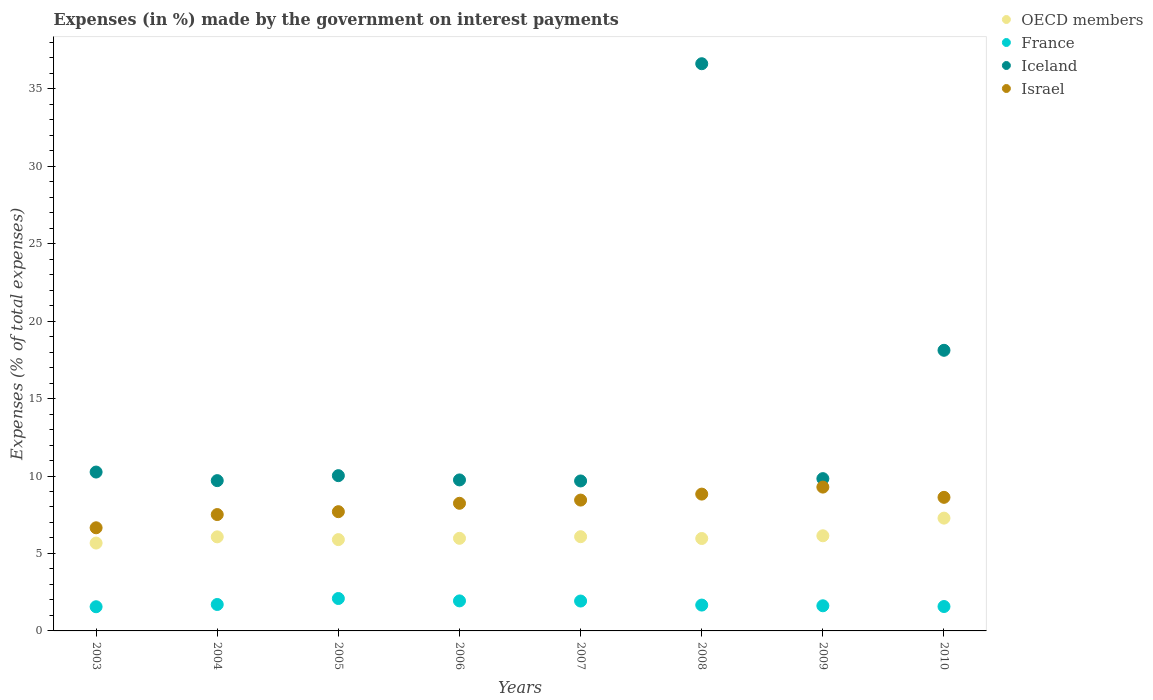How many different coloured dotlines are there?
Offer a very short reply. 4. What is the percentage of expenses made by the government on interest payments in France in 2005?
Make the answer very short. 2.09. Across all years, what is the maximum percentage of expenses made by the government on interest payments in Israel?
Offer a terse response. 9.28. Across all years, what is the minimum percentage of expenses made by the government on interest payments in France?
Offer a terse response. 1.56. In which year was the percentage of expenses made by the government on interest payments in OECD members minimum?
Offer a terse response. 2003. What is the total percentage of expenses made by the government on interest payments in OECD members in the graph?
Provide a short and direct response. 49.08. What is the difference between the percentage of expenses made by the government on interest payments in France in 2007 and that in 2009?
Give a very brief answer. 0.31. What is the difference between the percentage of expenses made by the government on interest payments in OECD members in 2004 and the percentage of expenses made by the government on interest payments in France in 2010?
Provide a short and direct response. 4.5. What is the average percentage of expenses made by the government on interest payments in France per year?
Provide a short and direct response. 1.76. In the year 2009, what is the difference between the percentage of expenses made by the government on interest payments in Iceland and percentage of expenses made by the government on interest payments in France?
Offer a terse response. 8.21. In how many years, is the percentage of expenses made by the government on interest payments in France greater than 9 %?
Make the answer very short. 0. What is the ratio of the percentage of expenses made by the government on interest payments in OECD members in 2006 to that in 2007?
Your answer should be compact. 0.98. Is the percentage of expenses made by the government on interest payments in Israel in 2008 less than that in 2010?
Offer a terse response. No. Is the difference between the percentage of expenses made by the government on interest payments in Iceland in 2006 and 2010 greater than the difference between the percentage of expenses made by the government on interest payments in France in 2006 and 2010?
Your answer should be compact. No. What is the difference between the highest and the second highest percentage of expenses made by the government on interest payments in Iceland?
Provide a succinct answer. 18.5. What is the difference between the highest and the lowest percentage of expenses made by the government on interest payments in Iceland?
Your response must be concise. 26.93. In how many years, is the percentage of expenses made by the government on interest payments in France greater than the average percentage of expenses made by the government on interest payments in France taken over all years?
Offer a terse response. 3. Is it the case that in every year, the sum of the percentage of expenses made by the government on interest payments in OECD members and percentage of expenses made by the government on interest payments in France  is greater than the sum of percentage of expenses made by the government on interest payments in Iceland and percentage of expenses made by the government on interest payments in Israel?
Your answer should be very brief. Yes. Does the percentage of expenses made by the government on interest payments in Iceland monotonically increase over the years?
Give a very brief answer. No. Is the percentage of expenses made by the government on interest payments in Iceland strictly greater than the percentage of expenses made by the government on interest payments in France over the years?
Keep it short and to the point. Yes. Is the percentage of expenses made by the government on interest payments in OECD members strictly less than the percentage of expenses made by the government on interest payments in Israel over the years?
Keep it short and to the point. Yes. How many years are there in the graph?
Make the answer very short. 8. Are the values on the major ticks of Y-axis written in scientific E-notation?
Your answer should be compact. No. Does the graph contain grids?
Your response must be concise. No. Where does the legend appear in the graph?
Give a very brief answer. Top right. How many legend labels are there?
Your answer should be compact. 4. What is the title of the graph?
Your answer should be compact. Expenses (in %) made by the government on interest payments. What is the label or title of the Y-axis?
Provide a succinct answer. Expenses (% of total expenses). What is the Expenses (% of total expenses) of OECD members in 2003?
Your response must be concise. 5.67. What is the Expenses (% of total expenses) of France in 2003?
Your answer should be compact. 1.56. What is the Expenses (% of total expenses) of Iceland in 2003?
Keep it short and to the point. 10.26. What is the Expenses (% of total expenses) of Israel in 2003?
Your response must be concise. 6.66. What is the Expenses (% of total expenses) in OECD members in 2004?
Your answer should be compact. 6.07. What is the Expenses (% of total expenses) in France in 2004?
Make the answer very short. 1.71. What is the Expenses (% of total expenses) in Iceland in 2004?
Provide a succinct answer. 9.7. What is the Expenses (% of total expenses) of Israel in 2004?
Keep it short and to the point. 7.51. What is the Expenses (% of total expenses) of OECD members in 2005?
Give a very brief answer. 5.89. What is the Expenses (% of total expenses) in France in 2005?
Make the answer very short. 2.09. What is the Expenses (% of total expenses) of Iceland in 2005?
Your answer should be compact. 10.02. What is the Expenses (% of total expenses) of Israel in 2005?
Offer a very short reply. 7.7. What is the Expenses (% of total expenses) of OECD members in 2006?
Offer a terse response. 5.98. What is the Expenses (% of total expenses) of France in 2006?
Give a very brief answer. 1.94. What is the Expenses (% of total expenses) in Iceland in 2006?
Offer a very short reply. 9.75. What is the Expenses (% of total expenses) of Israel in 2006?
Keep it short and to the point. 8.24. What is the Expenses (% of total expenses) in OECD members in 2007?
Your answer should be very brief. 6.08. What is the Expenses (% of total expenses) of France in 2007?
Ensure brevity in your answer.  1.93. What is the Expenses (% of total expenses) of Iceland in 2007?
Your response must be concise. 9.68. What is the Expenses (% of total expenses) in Israel in 2007?
Your answer should be very brief. 8.45. What is the Expenses (% of total expenses) of OECD members in 2008?
Offer a terse response. 5.97. What is the Expenses (% of total expenses) in France in 2008?
Offer a terse response. 1.67. What is the Expenses (% of total expenses) in Iceland in 2008?
Provide a succinct answer. 36.61. What is the Expenses (% of total expenses) of Israel in 2008?
Give a very brief answer. 8.83. What is the Expenses (% of total expenses) of OECD members in 2009?
Offer a terse response. 6.14. What is the Expenses (% of total expenses) in France in 2009?
Your answer should be compact. 1.62. What is the Expenses (% of total expenses) of Iceland in 2009?
Keep it short and to the point. 9.83. What is the Expenses (% of total expenses) of Israel in 2009?
Provide a succinct answer. 9.28. What is the Expenses (% of total expenses) in OECD members in 2010?
Provide a succinct answer. 7.28. What is the Expenses (% of total expenses) in France in 2010?
Keep it short and to the point. 1.58. What is the Expenses (% of total expenses) in Iceland in 2010?
Ensure brevity in your answer.  18.11. What is the Expenses (% of total expenses) of Israel in 2010?
Your response must be concise. 8.62. Across all years, what is the maximum Expenses (% of total expenses) of OECD members?
Keep it short and to the point. 7.28. Across all years, what is the maximum Expenses (% of total expenses) in France?
Provide a short and direct response. 2.09. Across all years, what is the maximum Expenses (% of total expenses) of Iceland?
Provide a short and direct response. 36.61. Across all years, what is the maximum Expenses (% of total expenses) of Israel?
Your response must be concise. 9.28. Across all years, what is the minimum Expenses (% of total expenses) of OECD members?
Offer a terse response. 5.67. Across all years, what is the minimum Expenses (% of total expenses) of France?
Your response must be concise. 1.56. Across all years, what is the minimum Expenses (% of total expenses) in Iceland?
Your answer should be very brief. 9.68. Across all years, what is the minimum Expenses (% of total expenses) of Israel?
Keep it short and to the point. 6.66. What is the total Expenses (% of total expenses) of OECD members in the graph?
Your answer should be very brief. 49.08. What is the total Expenses (% of total expenses) in France in the graph?
Keep it short and to the point. 14.09. What is the total Expenses (% of total expenses) in Iceland in the graph?
Provide a succinct answer. 113.96. What is the total Expenses (% of total expenses) in Israel in the graph?
Give a very brief answer. 65.29. What is the difference between the Expenses (% of total expenses) in OECD members in 2003 and that in 2004?
Keep it short and to the point. -0.4. What is the difference between the Expenses (% of total expenses) of France in 2003 and that in 2004?
Make the answer very short. -0.15. What is the difference between the Expenses (% of total expenses) in Iceland in 2003 and that in 2004?
Keep it short and to the point. 0.55. What is the difference between the Expenses (% of total expenses) of Israel in 2003 and that in 2004?
Ensure brevity in your answer.  -0.85. What is the difference between the Expenses (% of total expenses) of OECD members in 2003 and that in 2005?
Provide a short and direct response. -0.22. What is the difference between the Expenses (% of total expenses) of France in 2003 and that in 2005?
Your answer should be very brief. -0.53. What is the difference between the Expenses (% of total expenses) of Iceland in 2003 and that in 2005?
Provide a short and direct response. 0.23. What is the difference between the Expenses (% of total expenses) in Israel in 2003 and that in 2005?
Offer a very short reply. -1.04. What is the difference between the Expenses (% of total expenses) in OECD members in 2003 and that in 2006?
Your response must be concise. -0.31. What is the difference between the Expenses (% of total expenses) in France in 2003 and that in 2006?
Keep it short and to the point. -0.38. What is the difference between the Expenses (% of total expenses) in Iceland in 2003 and that in 2006?
Ensure brevity in your answer.  0.51. What is the difference between the Expenses (% of total expenses) in Israel in 2003 and that in 2006?
Ensure brevity in your answer.  -1.58. What is the difference between the Expenses (% of total expenses) of OECD members in 2003 and that in 2007?
Your answer should be very brief. -0.41. What is the difference between the Expenses (% of total expenses) in France in 2003 and that in 2007?
Your answer should be compact. -0.37. What is the difference between the Expenses (% of total expenses) of Iceland in 2003 and that in 2007?
Keep it short and to the point. 0.57. What is the difference between the Expenses (% of total expenses) of Israel in 2003 and that in 2007?
Your answer should be compact. -1.79. What is the difference between the Expenses (% of total expenses) of OECD members in 2003 and that in 2008?
Keep it short and to the point. -0.29. What is the difference between the Expenses (% of total expenses) in France in 2003 and that in 2008?
Provide a succinct answer. -0.11. What is the difference between the Expenses (% of total expenses) of Iceland in 2003 and that in 2008?
Keep it short and to the point. -26.36. What is the difference between the Expenses (% of total expenses) in Israel in 2003 and that in 2008?
Keep it short and to the point. -2.17. What is the difference between the Expenses (% of total expenses) in OECD members in 2003 and that in 2009?
Offer a terse response. -0.47. What is the difference between the Expenses (% of total expenses) of France in 2003 and that in 2009?
Provide a succinct answer. -0.06. What is the difference between the Expenses (% of total expenses) in Iceland in 2003 and that in 2009?
Your answer should be compact. 0.42. What is the difference between the Expenses (% of total expenses) of Israel in 2003 and that in 2009?
Provide a short and direct response. -2.63. What is the difference between the Expenses (% of total expenses) in OECD members in 2003 and that in 2010?
Provide a short and direct response. -1.61. What is the difference between the Expenses (% of total expenses) in France in 2003 and that in 2010?
Offer a terse response. -0.01. What is the difference between the Expenses (% of total expenses) in Iceland in 2003 and that in 2010?
Ensure brevity in your answer.  -7.86. What is the difference between the Expenses (% of total expenses) in Israel in 2003 and that in 2010?
Ensure brevity in your answer.  -1.96. What is the difference between the Expenses (% of total expenses) of OECD members in 2004 and that in 2005?
Give a very brief answer. 0.18. What is the difference between the Expenses (% of total expenses) of France in 2004 and that in 2005?
Keep it short and to the point. -0.39. What is the difference between the Expenses (% of total expenses) of Iceland in 2004 and that in 2005?
Provide a short and direct response. -0.32. What is the difference between the Expenses (% of total expenses) of Israel in 2004 and that in 2005?
Your response must be concise. -0.19. What is the difference between the Expenses (% of total expenses) in OECD members in 2004 and that in 2006?
Offer a terse response. 0.09. What is the difference between the Expenses (% of total expenses) in France in 2004 and that in 2006?
Your response must be concise. -0.23. What is the difference between the Expenses (% of total expenses) in Iceland in 2004 and that in 2006?
Provide a succinct answer. -0.05. What is the difference between the Expenses (% of total expenses) in Israel in 2004 and that in 2006?
Your answer should be compact. -0.73. What is the difference between the Expenses (% of total expenses) in OECD members in 2004 and that in 2007?
Provide a succinct answer. -0.01. What is the difference between the Expenses (% of total expenses) in France in 2004 and that in 2007?
Your answer should be compact. -0.22. What is the difference between the Expenses (% of total expenses) in Iceland in 2004 and that in 2007?
Your answer should be very brief. 0.02. What is the difference between the Expenses (% of total expenses) in Israel in 2004 and that in 2007?
Your answer should be compact. -0.93. What is the difference between the Expenses (% of total expenses) of OECD members in 2004 and that in 2008?
Your response must be concise. 0.11. What is the difference between the Expenses (% of total expenses) of France in 2004 and that in 2008?
Ensure brevity in your answer.  0.04. What is the difference between the Expenses (% of total expenses) of Iceland in 2004 and that in 2008?
Offer a very short reply. -26.91. What is the difference between the Expenses (% of total expenses) of Israel in 2004 and that in 2008?
Offer a terse response. -1.32. What is the difference between the Expenses (% of total expenses) in OECD members in 2004 and that in 2009?
Your answer should be compact. -0.07. What is the difference between the Expenses (% of total expenses) in France in 2004 and that in 2009?
Make the answer very short. 0.08. What is the difference between the Expenses (% of total expenses) of Iceland in 2004 and that in 2009?
Keep it short and to the point. -0.13. What is the difference between the Expenses (% of total expenses) in Israel in 2004 and that in 2009?
Your response must be concise. -1.77. What is the difference between the Expenses (% of total expenses) in OECD members in 2004 and that in 2010?
Your answer should be very brief. -1.21. What is the difference between the Expenses (% of total expenses) in France in 2004 and that in 2010?
Keep it short and to the point. 0.13. What is the difference between the Expenses (% of total expenses) in Iceland in 2004 and that in 2010?
Your response must be concise. -8.41. What is the difference between the Expenses (% of total expenses) of Israel in 2004 and that in 2010?
Your answer should be very brief. -1.11. What is the difference between the Expenses (% of total expenses) in OECD members in 2005 and that in 2006?
Provide a succinct answer. -0.08. What is the difference between the Expenses (% of total expenses) in France in 2005 and that in 2006?
Your response must be concise. 0.15. What is the difference between the Expenses (% of total expenses) of Iceland in 2005 and that in 2006?
Provide a short and direct response. 0.28. What is the difference between the Expenses (% of total expenses) in Israel in 2005 and that in 2006?
Give a very brief answer. -0.54. What is the difference between the Expenses (% of total expenses) in OECD members in 2005 and that in 2007?
Provide a short and direct response. -0.19. What is the difference between the Expenses (% of total expenses) of France in 2005 and that in 2007?
Make the answer very short. 0.16. What is the difference between the Expenses (% of total expenses) in Iceland in 2005 and that in 2007?
Your answer should be very brief. 0.34. What is the difference between the Expenses (% of total expenses) in Israel in 2005 and that in 2007?
Offer a terse response. -0.75. What is the difference between the Expenses (% of total expenses) in OECD members in 2005 and that in 2008?
Provide a succinct answer. -0.07. What is the difference between the Expenses (% of total expenses) of France in 2005 and that in 2008?
Your response must be concise. 0.42. What is the difference between the Expenses (% of total expenses) of Iceland in 2005 and that in 2008?
Your response must be concise. -26.59. What is the difference between the Expenses (% of total expenses) of Israel in 2005 and that in 2008?
Your answer should be very brief. -1.13. What is the difference between the Expenses (% of total expenses) of OECD members in 2005 and that in 2009?
Keep it short and to the point. -0.25. What is the difference between the Expenses (% of total expenses) in France in 2005 and that in 2009?
Offer a terse response. 0.47. What is the difference between the Expenses (% of total expenses) of Iceland in 2005 and that in 2009?
Keep it short and to the point. 0.19. What is the difference between the Expenses (% of total expenses) in Israel in 2005 and that in 2009?
Give a very brief answer. -1.59. What is the difference between the Expenses (% of total expenses) in OECD members in 2005 and that in 2010?
Offer a terse response. -1.39. What is the difference between the Expenses (% of total expenses) of France in 2005 and that in 2010?
Your answer should be compact. 0.52. What is the difference between the Expenses (% of total expenses) in Iceland in 2005 and that in 2010?
Ensure brevity in your answer.  -8.09. What is the difference between the Expenses (% of total expenses) of Israel in 2005 and that in 2010?
Your answer should be very brief. -0.93. What is the difference between the Expenses (% of total expenses) of OECD members in 2006 and that in 2007?
Ensure brevity in your answer.  -0.1. What is the difference between the Expenses (% of total expenses) in Iceland in 2006 and that in 2007?
Your answer should be compact. 0.07. What is the difference between the Expenses (% of total expenses) of Israel in 2006 and that in 2007?
Your answer should be compact. -0.21. What is the difference between the Expenses (% of total expenses) of OECD members in 2006 and that in 2008?
Make the answer very short. 0.01. What is the difference between the Expenses (% of total expenses) in France in 2006 and that in 2008?
Your response must be concise. 0.27. What is the difference between the Expenses (% of total expenses) in Iceland in 2006 and that in 2008?
Offer a terse response. -26.86. What is the difference between the Expenses (% of total expenses) of Israel in 2006 and that in 2008?
Keep it short and to the point. -0.59. What is the difference between the Expenses (% of total expenses) in OECD members in 2006 and that in 2009?
Make the answer very short. -0.16. What is the difference between the Expenses (% of total expenses) of France in 2006 and that in 2009?
Your answer should be compact. 0.32. What is the difference between the Expenses (% of total expenses) of Iceland in 2006 and that in 2009?
Give a very brief answer. -0.08. What is the difference between the Expenses (% of total expenses) in Israel in 2006 and that in 2009?
Provide a succinct answer. -1.05. What is the difference between the Expenses (% of total expenses) in OECD members in 2006 and that in 2010?
Keep it short and to the point. -1.3. What is the difference between the Expenses (% of total expenses) in France in 2006 and that in 2010?
Give a very brief answer. 0.36. What is the difference between the Expenses (% of total expenses) in Iceland in 2006 and that in 2010?
Give a very brief answer. -8.37. What is the difference between the Expenses (% of total expenses) of Israel in 2006 and that in 2010?
Ensure brevity in your answer.  -0.38. What is the difference between the Expenses (% of total expenses) in OECD members in 2007 and that in 2008?
Provide a succinct answer. 0.12. What is the difference between the Expenses (% of total expenses) in France in 2007 and that in 2008?
Your answer should be very brief. 0.26. What is the difference between the Expenses (% of total expenses) in Iceland in 2007 and that in 2008?
Offer a very short reply. -26.93. What is the difference between the Expenses (% of total expenses) in Israel in 2007 and that in 2008?
Ensure brevity in your answer.  -0.39. What is the difference between the Expenses (% of total expenses) of OECD members in 2007 and that in 2009?
Your response must be concise. -0.06. What is the difference between the Expenses (% of total expenses) in France in 2007 and that in 2009?
Your answer should be very brief. 0.31. What is the difference between the Expenses (% of total expenses) of Iceland in 2007 and that in 2009?
Keep it short and to the point. -0.15. What is the difference between the Expenses (% of total expenses) of Israel in 2007 and that in 2009?
Your answer should be very brief. -0.84. What is the difference between the Expenses (% of total expenses) in OECD members in 2007 and that in 2010?
Make the answer very short. -1.2. What is the difference between the Expenses (% of total expenses) in France in 2007 and that in 2010?
Ensure brevity in your answer.  0.35. What is the difference between the Expenses (% of total expenses) of Iceland in 2007 and that in 2010?
Give a very brief answer. -8.43. What is the difference between the Expenses (% of total expenses) in Israel in 2007 and that in 2010?
Make the answer very short. -0.18. What is the difference between the Expenses (% of total expenses) of OECD members in 2008 and that in 2009?
Your response must be concise. -0.18. What is the difference between the Expenses (% of total expenses) in France in 2008 and that in 2009?
Your answer should be compact. 0.05. What is the difference between the Expenses (% of total expenses) in Iceland in 2008 and that in 2009?
Provide a short and direct response. 26.78. What is the difference between the Expenses (% of total expenses) of Israel in 2008 and that in 2009?
Your answer should be compact. -0.45. What is the difference between the Expenses (% of total expenses) in OECD members in 2008 and that in 2010?
Provide a short and direct response. -1.32. What is the difference between the Expenses (% of total expenses) in France in 2008 and that in 2010?
Ensure brevity in your answer.  0.09. What is the difference between the Expenses (% of total expenses) in Iceland in 2008 and that in 2010?
Offer a very short reply. 18.5. What is the difference between the Expenses (% of total expenses) of Israel in 2008 and that in 2010?
Make the answer very short. 0.21. What is the difference between the Expenses (% of total expenses) in OECD members in 2009 and that in 2010?
Your response must be concise. -1.14. What is the difference between the Expenses (% of total expenses) in France in 2009 and that in 2010?
Provide a short and direct response. 0.05. What is the difference between the Expenses (% of total expenses) in Iceland in 2009 and that in 2010?
Make the answer very short. -8.28. What is the difference between the Expenses (% of total expenses) in Israel in 2009 and that in 2010?
Provide a succinct answer. 0.66. What is the difference between the Expenses (% of total expenses) in OECD members in 2003 and the Expenses (% of total expenses) in France in 2004?
Make the answer very short. 3.96. What is the difference between the Expenses (% of total expenses) in OECD members in 2003 and the Expenses (% of total expenses) in Iceland in 2004?
Offer a terse response. -4.03. What is the difference between the Expenses (% of total expenses) in OECD members in 2003 and the Expenses (% of total expenses) in Israel in 2004?
Give a very brief answer. -1.84. What is the difference between the Expenses (% of total expenses) of France in 2003 and the Expenses (% of total expenses) of Iceland in 2004?
Make the answer very short. -8.14. What is the difference between the Expenses (% of total expenses) of France in 2003 and the Expenses (% of total expenses) of Israel in 2004?
Make the answer very short. -5.95. What is the difference between the Expenses (% of total expenses) of Iceland in 2003 and the Expenses (% of total expenses) of Israel in 2004?
Your answer should be compact. 2.74. What is the difference between the Expenses (% of total expenses) in OECD members in 2003 and the Expenses (% of total expenses) in France in 2005?
Your response must be concise. 3.58. What is the difference between the Expenses (% of total expenses) of OECD members in 2003 and the Expenses (% of total expenses) of Iceland in 2005?
Offer a very short reply. -4.35. What is the difference between the Expenses (% of total expenses) in OECD members in 2003 and the Expenses (% of total expenses) in Israel in 2005?
Offer a very short reply. -2.03. What is the difference between the Expenses (% of total expenses) of France in 2003 and the Expenses (% of total expenses) of Iceland in 2005?
Provide a short and direct response. -8.46. What is the difference between the Expenses (% of total expenses) of France in 2003 and the Expenses (% of total expenses) of Israel in 2005?
Give a very brief answer. -6.14. What is the difference between the Expenses (% of total expenses) in Iceland in 2003 and the Expenses (% of total expenses) in Israel in 2005?
Give a very brief answer. 2.56. What is the difference between the Expenses (% of total expenses) in OECD members in 2003 and the Expenses (% of total expenses) in France in 2006?
Make the answer very short. 3.73. What is the difference between the Expenses (% of total expenses) in OECD members in 2003 and the Expenses (% of total expenses) in Iceland in 2006?
Offer a very short reply. -4.08. What is the difference between the Expenses (% of total expenses) in OECD members in 2003 and the Expenses (% of total expenses) in Israel in 2006?
Ensure brevity in your answer.  -2.57. What is the difference between the Expenses (% of total expenses) in France in 2003 and the Expenses (% of total expenses) in Iceland in 2006?
Your answer should be very brief. -8.19. What is the difference between the Expenses (% of total expenses) in France in 2003 and the Expenses (% of total expenses) in Israel in 2006?
Offer a terse response. -6.68. What is the difference between the Expenses (% of total expenses) in Iceland in 2003 and the Expenses (% of total expenses) in Israel in 2006?
Give a very brief answer. 2.02. What is the difference between the Expenses (% of total expenses) in OECD members in 2003 and the Expenses (% of total expenses) in France in 2007?
Keep it short and to the point. 3.74. What is the difference between the Expenses (% of total expenses) in OECD members in 2003 and the Expenses (% of total expenses) in Iceland in 2007?
Offer a terse response. -4.01. What is the difference between the Expenses (% of total expenses) of OECD members in 2003 and the Expenses (% of total expenses) of Israel in 2007?
Ensure brevity in your answer.  -2.77. What is the difference between the Expenses (% of total expenses) of France in 2003 and the Expenses (% of total expenses) of Iceland in 2007?
Give a very brief answer. -8.12. What is the difference between the Expenses (% of total expenses) in France in 2003 and the Expenses (% of total expenses) in Israel in 2007?
Provide a short and direct response. -6.88. What is the difference between the Expenses (% of total expenses) in Iceland in 2003 and the Expenses (% of total expenses) in Israel in 2007?
Give a very brief answer. 1.81. What is the difference between the Expenses (% of total expenses) in OECD members in 2003 and the Expenses (% of total expenses) in France in 2008?
Keep it short and to the point. 4. What is the difference between the Expenses (% of total expenses) in OECD members in 2003 and the Expenses (% of total expenses) in Iceland in 2008?
Your answer should be compact. -30.94. What is the difference between the Expenses (% of total expenses) of OECD members in 2003 and the Expenses (% of total expenses) of Israel in 2008?
Provide a succinct answer. -3.16. What is the difference between the Expenses (% of total expenses) of France in 2003 and the Expenses (% of total expenses) of Iceland in 2008?
Keep it short and to the point. -35.05. What is the difference between the Expenses (% of total expenses) in France in 2003 and the Expenses (% of total expenses) in Israel in 2008?
Your response must be concise. -7.27. What is the difference between the Expenses (% of total expenses) in Iceland in 2003 and the Expenses (% of total expenses) in Israel in 2008?
Keep it short and to the point. 1.42. What is the difference between the Expenses (% of total expenses) in OECD members in 2003 and the Expenses (% of total expenses) in France in 2009?
Make the answer very short. 4.05. What is the difference between the Expenses (% of total expenses) in OECD members in 2003 and the Expenses (% of total expenses) in Iceland in 2009?
Make the answer very short. -4.16. What is the difference between the Expenses (% of total expenses) in OECD members in 2003 and the Expenses (% of total expenses) in Israel in 2009?
Provide a short and direct response. -3.61. What is the difference between the Expenses (% of total expenses) of France in 2003 and the Expenses (% of total expenses) of Iceland in 2009?
Provide a succinct answer. -8.27. What is the difference between the Expenses (% of total expenses) in France in 2003 and the Expenses (% of total expenses) in Israel in 2009?
Provide a short and direct response. -7.72. What is the difference between the Expenses (% of total expenses) of Iceland in 2003 and the Expenses (% of total expenses) of Israel in 2009?
Your answer should be compact. 0.97. What is the difference between the Expenses (% of total expenses) in OECD members in 2003 and the Expenses (% of total expenses) in France in 2010?
Your answer should be very brief. 4.1. What is the difference between the Expenses (% of total expenses) in OECD members in 2003 and the Expenses (% of total expenses) in Iceland in 2010?
Your response must be concise. -12.44. What is the difference between the Expenses (% of total expenses) in OECD members in 2003 and the Expenses (% of total expenses) in Israel in 2010?
Ensure brevity in your answer.  -2.95. What is the difference between the Expenses (% of total expenses) of France in 2003 and the Expenses (% of total expenses) of Iceland in 2010?
Offer a very short reply. -16.55. What is the difference between the Expenses (% of total expenses) of France in 2003 and the Expenses (% of total expenses) of Israel in 2010?
Give a very brief answer. -7.06. What is the difference between the Expenses (% of total expenses) in Iceland in 2003 and the Expenses (% of total expenses) in Israel in 2010?
Your answer should be compact. 1.63. What is the difference between the Expenses (% of total expenses) in OECD members in 2004 and the Expenses (% of total expenses) in France in 2005?
Offer a terse response. 3.98. What is the difference between the Expenses (% of total expenses) of OECD members in 2004 and the Expenses (% of total expenses) of Iceland in 2005?
Provide a succinct answer. -3.95. What is the difference between the Expenses (% of total expenses) of OECD members in 2004 and the Expenses (% of total expenses) of Israel in 2005?
Provide a succinct answer. -1.62. What is the difference between the Expenses (% of total expenses) of France in 2004 and the Expenses (% of total expenses) of Iceland in 2005?
Provide a succinct answer. -8.32. What is the difference between the Expenses (% of total expenses) of France in 2004 and the Expenses (% of total expenses) of Israel in 2005?
Provide a short and direct response. -5.99. What is the difference between the Expenses (% of total expenses) in Iceland in 2004 and the Expenses (% of total expenses) in Israel in 2005?
Provide a succinct answer. 2. What is the difference between the Expenses (% of total expenses) of OECD members in 2004 and the Expenses (% of total expenses) of France in 2006?
Your response must be concise. 4.13. What is the difference between the Expenses (% of total expenses) of OECD members in 2004 and the Expenses (% of total expenses) of Iceland in 2006?
Give a very brief answer. -3.68. What is the difference between the Expenses (% of total expenses) of OECD members in 2004 and the Expenses (% of total expenses) of Israel in 2006?
Provide a succinct answer. -2.17. What is the difference between the Expenses (% of total expenses) in France in 2004 and the Expenses (% of total expenses) in Iceland in 2006?
Give a very brief answer. -8.04. What is the difference between the Expenses (% of total expenses) of France in 2004 and the Expenses (% of total expenses) of Israel in 2006?
Offer a very short reply. -6.53. What is the difference between the Expenses (% of total expenses) of Iceland in 2004 and the Expenses (% of total expenses) of Israel in 2006?
Keep it short and to the point. 1.46. What is the difference between the Expenses (% of total expenses) of OECD members in 2004 and the Expenses (% of total expenses) of France in 2007?
Ensure brevity in your answer.  4.14. What is the difference between the Expenses (% of total expenses) in OECD members in 2004 and the Expenses (% of total expenses) in Iceland in 2007?
Your answer should be compact. -3.61. What is the difference between the Expenses (% of total expenses) in OECD members in 2004 and the Expenses (% of total expenses) in Israel in 2007?
Provide a short and direct response. -2.37. What is the difference between the Expenses (% of total expenses) in France in 2004 and the Expenses (% of total expenses) in Iceland in 2007?
Your response must be concise. -7.97. What is the difference between the Expenses (% of total expenses) of France in 2004 and the Expenses (% of total expenses) of Israel in 2007?
Your answer should be compact. -6.74. What is the difference between the Expenses (% of total expenses) in Iceland in 2004 and the Expenses (% of total expenses) in Israel in 2007?
Your answer should be compact. 1.26. What is the difference between the Expenses (% of total expenses) in OECD members in 2004 and the Expenses (% of total expenses) in France in 2008?
Provide a succinct answer. 4.4. What is the difference between the Expenses (% of total expenses) in OECD members in 2004 and the Expenses (% of total expenses) in Iceland in 2008?
Make the answer very short. -30.54. What is the difference between the Expenses (% of total expenses) of OECD members in 2004 and the Expenses (% of total expenses) of Israel in 2008?
Your response must be concise. -2.76. What is the difference between the Expenses (% of total expenses) of France in 2004 and the Expenses (% of total expenses) of Iceland in 2008?
Offer a terse response. -34.91. What is the difference between the Expenses (% of total expenses) in France in 2004 and the Expenses (% of total expenses) in Israel in 2008?
Ensure brevity in your answer.  -7.12. What is the difference between the Expenses (% of total expenses) in Iceland in 2004 and the Expenses (% of total expenses) in Israel in 2008?
Provide a short and direct response. 0.87. What is the difference between the Expenses (% of total expenses) of OECD members in 2004 and the Expenses (% of total expenses) of France in 2009?
Give a very brief answer. 4.45. What is the difference between the Expenses (% of total expenses) of OECD members in 2004 and the Expenses (% of total expenses) of Iceland in 2009?
Keep it short and to the point. -3.76. What is the difference between the Expenses (% of total expenses) of OECD members in 2004 and the Expenses (% of total expenses) of Israel in 2009?
Make the answer very short. -3.21. What is the difference between the Expenses (% of total expenses) in France in 2004 and the Expenses (% of total expenses) in Iceland in 2009?
Your answer should be compact. -8.12. What is the difference between the Expenses (% of total expenses) in France in 2004 and the Expenses (% of total expenses) in Israel in 2009?
Provide a succinct answer. -7.58. What is the difference between the Expenses (% of total expenses) of Iceland in 2004 and the Expenses (% of total expenses) of Israel in 2009?
Provide a succinct answer. 0.42. What is the difference between the Expenses (% of total expenses) in OECD members in 2004 and the Expenses (% of total expenses) in France in 2010?
Offer a very short reply. 4.5. What is the difference between the Expenses (% of total expenses) of OECD members in 2004 and the Expenses (% of total expenses) of Iceland in 2010?
Your response must be concise. -12.04. What is the difference between the Expenses (% of total expenses) in OECD members in 2004 and the Expenses (% of total expenses) in Israel in 2010?
Offer a terse response. -2.55. What is the difference between the Expenses (% of total expenses) in France in 2004 and the Expenses (% of total expenses) in Iceland in 2010?
Ensure brevity in your answer.  -16.41. What is the difference between the Expenses (% of total expenses) in France in 2004 and the Expenses (% of total expenses) in Israel in 2010?
Keep it short and to the point. -6.92. What is the difference between the Expenses (% of total expenses) in Iceland in 2004 and the Expenses (% of total expenses) in Israel in 2010?
Offer a very short reply. 1.08. What is the difference between the Expenses (% of total expenses) of OECD members in 2005 and the Expenses (% of total expenses) of France in 2006?
Keep it short and to the point. 3.96. What is the difference between the Expenses (% of total expenses) of OECD members in 2005 and the Expenses (% of total expenses) of Iceland in 2006?
Your answer should be very brief. -3.85. What is the difference between the Expenses (% of total expenses) of OECD members in 2005 and the Expenses (% of total expenses) of Israel in 2006?
Ensure brevity in your answer.  -2.34. What is the difference between the Expenses (% of total expenses) of France in 2005 and the Expenses (% of total expenses) of Iceland in 2006?
Offer a terse response. -7.65. What is the difference between the Expenses (% of total expenses) of France in 2005 and the Expenses (% of total expenses) of Israel in 2006?
Your answer should be compact. -6.15. What is the difference between the Expenses (% of total expenses) in Iceland in 2005 and the Expenses (% of total expenses) in Israel in 2006?
Your response must be concise. 1.78. What is the difference between the Expenses (% of total expenses) of OECD members in 2005 and the Expenses (% of total expenses) of France in 2007?
Give a very brief answer. 3.97. What is the difference between the Expenses (% of total expenses) of OECD members in 2005 and the Expenses (% of total expenses) of Iceland in 2007?
Keep it short and to the point. -3.79. What is the difference between the Expenses (% of total expenses) of OECD members in 2005 and the Expenses (% of total expenses) of Israel in 2007?
Give a very brief answer. -2.55. What is the difference between the Expenses (% of total expenses) in France in 2005 and the Expenses (% of total expenses) in Iceland in 2007?
Ensure brevity in your answer.  -7.59. What is the difference between the Expenses (% of total expenses) in France in 2005 and the Expenses (% of total expenses) in Israel in 2007?
Provide a short and direct response. -6.35. What is the difference between the Expenses (% of total expenses) in Iceland in 2005 and the Expenses (% of total expenses) in Israel in 2007?
Give a very brief answer. 1.58. What is the difference between the Expenses (% of total expenses) in OECD members in 2005 and the Expenses (% of total expenses) in France in 2008?
Your answer should be very brief. 4.23. What is the difference between the Expenses (% of total expenses) in OECD members in 2005 and the Expenses (% of total expenses) in Iceland in 2008?
Offer a terse response. -30.72. What is the difference between the Expenses (% of total expenses) of OECD members in 2005 and the Expenses (% of total expenses) of Israel in 2008?
Your answer should be compact. -2.94. What is the difference between the Expenses (% of total expenses) in France in 2005 and the Expenses (% of total expenses) in Iceland in 2008?
Ensure brevity in your answer.  -34.52. What is the difference between the Expenses (% of total expenses) of France in 2005 and the Expenses (% of total expenses) of Israel in 2008?
Give a very brief answer. -6.74. What is the difference between the Expenses (% of total expenses) in Iceland in 2005 and the Expenses (% of total expenses) in Israel in 2008?
Keep it short and to the point. 1.19. What is the difference between the Expenses (% of total expenses) in OECD members in 2005 and the Expenses (% of total expenses) in France in 2009?
Ensure brevity in your answer.  4.27. What is the difference between the Expenses (% of total expenses) of OECD members in 2005 and the Expenses (% of total expenses) of Iceland in 2009?
Give a very brief answer. -3.94. What is the difference between the Expenses (% of total expenses) of OECD members in 2005 and the Expenses (% of total expenses) of Israel in 2009?
Keep it short and to the point. -3.39. What is the difference between the Expenses (% of total expenses) of France in 2005 and the Expenses (% of total expenses) of Iceland in 2009?
Your answer should be compact. -7.74. What is the difference between the Expenses (% of total expenses) of France in 2005 and the Expenses (% of total expenses) of Israel in 2009?
Your response must be concise. -7.19. What is the difference between the Expenses (% of total expenses) in Iceland in 2005 and the Expenses (% of total expenses) in Israel in 2009?
Ensure brevity in your answer.  0.74. What is the difference between the Expenses (% of total expenses) of OECD members in 2005 and the Expenses (% of total expenses) of France in 2010?
Your answer should be very brief. 4.32. What is the difference between the Expenses (% of total expenses) in OECD members in 2005 and the Expenses (% of total expenses) in Iceland in 2010?
Your answer should be very brief. -12.22. What is the difference between the Expenses (% of total expenses) of OECD members in 2005 and the Expenses (% of total expenses) of Israel in 2010?
Your response must be concise. -2.73. What is the difference between the Expenses (% of total expenses) of France in 2005 and the Expenses (% of total expenses) of Iceland in 2010?
Ensure brevity in your answer.  -16.02. What is the difference between the Expenses (% of total expenses) in France in 2005 and the Expenses (% of total expenses) in Israel in 2010?
Provide a succinct answer. -6.53. What is the difference between the Expenses (% of total expenses) in Iceland in 2005 and the Expenses (% of total expenses) in Israel in 2010?
Offer a terse response. 1.4. What is the difference between the Expenses (% of total expenses) of OECD members in 2006 and the Expenses (% of total expenses) of France in 2007?
Ensure brevity in your answer.  4.05. What is the difference between the Expenses (% of total expenses) in OECD members in 2006 and the Expenses (% of total expenses) in Iceland in 2007?
Your answer should be very brief. -3.7. What is the difference between the Expenses (% of total expenses) in OECD members in 2006 and the Expenses (% of total expenses) in Israel in 2007?
Ensure brevity in your answer.  -2.47. What is the difference between the Expenses (% of total expenses) of France in 2006 and the Expenses (% of total expenses) of Iceland in 2007?
Offer a very short reply. -7.74. What is the difference between the Expenses (% of total expenses) of France in 2006 and the Expenses (% of total expenses) of Israel in 2007?
Offer a terse response. -6.51. What is the difference between the Expenses (% of total expenses) of Iceland in 2006 and the Expenses (% of total expenses) of Israel in 2007?
Your answer should be very brief. 1.3. What is the difference between the Expenses (% of total expenses) of OECD members in 2006 and the Expenses (% of total expenses) of France in 2008?
Your response must be concise. 4.31. What is the difference between the Expenses (% of total expenses) of OECD members in 2006 and the Expenses (% of total expenses) of Iceland in 2008?
Make the answer very short. -30.63. What is the difference between the Expenses (% of total expenses) in OECD members in 2006 and the Expenses (% of total expenses) in Israel in 2008?
Keep it short and to the point. -2.85. What is the difference between the Expenses (% of total expenses) in France in 2006 and the Expenses (% of total expenses) in Iceland in 2008?
Offer a very short reply. -34.67. What is the difference between the Expenses (% of total expenses) in France in 2006 and the Expenses (% of total expenses) in Israel in 2008?
Make the answer very short. -6.89. What is the difference between the Expenses (% of total expenses) in Iceland in 2006 and the Expenses (% of total expenses) in Israel in 2008?
Provide a succinct answer. 0.92. What is the difference between the Expenses (% of total expenses) of OECD members in 2006 and the Expenses (% of total expenses) of France in 2009?
Your response must be concise. 4.35. What is the difference between the Expenses (% of total expenses) in OECD members in 2006 and the Expenses (% of total expenses) in Iceland in 2009?
Make the answer very short. -3.85. What is the difference between the Expenses (% of total expenses) of OECD members in 2006 and the Expenses (% of total expenses) of Israel in 2009?
Make the answer very short. -3.31. What is the difference between the Expenses (% of total expenses) in France in 2006 and the Expenses (% of total expenses) in Iceland in 2009?
Ensure brevity in your answer.  -7.89. What is the difference between the Expenses (% of total expenses) in France in 2006 and the Expenses (% of total expenses) in Israel in 2009?
Provide a short and direct response. -7.35. What is the difference between the Expenses (% of total expenses) in Iceland in 2006 and the Expenses (% of total expenses) in Israel in 2009?
Offer a very short reply. 0.46. What is the difference between the Expenses (% of total expenses) of OECD members in 2006 and the Expenses (% of total expenses) of France in 2010?
Your answer should be compact. 4.4. What is the difference between the Expenses (% of total expenses) in OECD members in 2006 and the Expenses (% of total expenses) in Iceland in 2010?
Offer a terse response. -12.14. What is the difference between the Expenses (% of total expenses) in OECD members in 2006 and the Expenses (% of total expenses) in Israel in 2010?
Keep it short and to the point. -2.64. What is the difference between the Expenses (% of total expenses) in France in 2006 and the Expenses (% of total expenses) in Iceland in 2010?
Your response must be concise. -16.18. What is the difference between the Expenses (% of total expenses) of France in 2006 and the Expenses (% of total expenses) of Israel in 2010?
Offer a very short reply. -6.68. What is the difference between the Expenses (% of total expenses) of Iceland in 2006 and the Expenses (% of total expenses) of Israel in 2010?
Provide a succinct answer. 1.12. What is the difference between the Expenses (% of total expenses) in OECD members in 2007 and the Expenses (% of total expenses) in France in 2008?
Your answer should be very brief. 4.41. What is the difference between the Expenses (% of total expenses) in OECD members in 2007 and the Expenses (% of total expenses) in Iceland in 2008?
Make the answer very short. -30.53. What is the difference between the Expenses (% of total expenses) in OECD members in 2007 and the Expenses (% of total expenses) in Israel in 2008?
Provide a succinct answer. -2.75. What is the difference between the Expenses (% of total expenses) of France in 2007 and the Expenses (% of total expenses) of Iceland in 2008?
Keep it short and to the point. -34.68. What is the difference between the Expenses (% of total expenses) in France in 2007 and the Expenses (% of total expenses) in Israel in 2008?
Your response must be concise. -6.9. What is the difference between the Expenses (% of total expenses) in Iceland in 2007 and the Expenses (% of total expenses) in Israel in 2008?
Make the answer very short. 0.85. What is the difference between the Expenses (% of total expenses) in OECD members in 2007 and the Expenses (% of total expenses) in France in 2009?
Your answer should be compact. 4.46. What is the difference between the Expenses (% of total expenses) of OECD members in 2007 and the Expenses (% of total expenses) of Iceland in 2009?
Ensure brevity in your answer.  -3.75. What is the difference between the Expenses (% of total expenses) in OECD members in 2007 and the Expenses (% of total expenses) in Israel in 2009?
Provide a succinct answer. -3.2. What is the difference between the Expenses (% of total expenses) in France in 2007 and the Expenses (% of total expenses) in Iceland in 2009?
Ensure brevity in your answer.  -7.9. What is the difference between the Expenses (% of total expenses) of France in 2007 and the Expenses (% of total expenses) of Israel in 2009?
Your answer should be compact. -7.36. What is the difference between the Expenses (% of total expenses) in Iceland in 2007 and the Expenses (% of total expenses) in Israel in 2009?
Keep it short and to the point. 0.4. What is the difference between the Expenses (% of total expenses) of OECD members in 2007 and the Expenses (% of total expenses) of France in 2010?
Give a very brief answer. 4.51. What is the difference between the Expenses (% of total expenses) of OECD members in 2007 and the Expenses (% of total expenses) of Iceland in 2010?
Provide a succinct answer. -12.03. What is the difference between the Expenses (% of total expenses) in OECD members in 2007 and the Expenses (% of total expenses) in Israel in 2010?
Provide a succinct answer. -2.54. What is the difference between the Expenses (% of total expenses) of France in 2007 and the Expenses (% of total expenses) of Iceland in 2010?
Give a very brief answer. -16.19. What is the difference between the Expenses (% of total expenses) in France in 2007 and the Expenses (% of total expenses) in Israel in 2010?
Offer a terse response. -6.69. What is the difference between the Expenses (% of total expenses) in Iceland in 2007 and the Expenses (% of total expenses) in Israel in 2010?
Offer a very short reply. 1.06. What is the difference between the Expenses (% of total expenses) of OECD members in 2008 and the Expenses (% of total expenses) of France in 2009?
Offer a terse response. 4.34. What is the difference between the Expenses (% of total expenses) of OECD members in 2008 and the Expenses (% of total expenses) of Iceland in 2009?
Keep it short and to the point. -3.86. What is the difference between the Expenses (% of total expenses) in OECD members in 2008 and the Expenses (% of total expenses) in Israel in 2009?
Provide a succinct answer. -3.32. What is the difference between the Expenses (% of total expenses) in France in 2008 and the Expenses (% of total expenses) in Iceland in 2009?
Provide a short and direct response. -8.16. What is the difference between the Expenses (% of total expenses) of France in 2008 and the Expenses (% of total expenses) of Israel in 2009?
Ensure brevity in your answer.  -7.62. What is the difference between the Expenses (% of total expenses) of Iceland in 2008 and the Expenses (% of total expenses) of Israel in 2009?
Give a very brief answer. 27.33. What is the difference between the Expenses (% of total expenses) of OECD members in 2008 and the Expenses (% of total expenses) of France in 2010?
Provide a succinct answer. 4.39. What is the difference between the Expenses (% of total expenses) in OECD members in 2008 and the Expenses (% of total expenses) in Iceland in 2010?
Offer a very short reply. -12.15. What is the difference between the Expenses (% of total expenses) in OECD members in 2008 and the Expenses (% of total expenses) in Israel in 2010?
Your response must be concise. -2.66. What is the difference between the Expenses (% of total expenses) of France in 2008 and the Expenses (% of total expenses) of Iceland in 2010?
Offer a terse response. -16.45. What is the difference between the Expenses (% of total expenses) in France in 2008 and the Expenses (% of total expenses) in Israel in 2010?
Provide a short and direct response. -6.95. What is the difference between the Expenses (% of total expenses) of Iceland in 2008 and the Expenses (% of total expenses) of Israel in 2010?
Make the answer very short. 27.99. What is the difference between the Expenses (% of total expenses) in OECD members in 2009 and the Expenses (% of total expenses) in France in 2010?
Your answer should be compact. 4.57. What is the difference between the Expenses (% of total expenses) in OECD members in 2009 and the Expenses (% of total expenses) in Iceland in 2010?
Keep it short and to the point. -11.97. What is the difference between the Expenses (% of total expenses) in OECD members in 2009 and the Expenses (% of total expenses) in Israel in 2010?
Offer a very short reply. -2.48. What is the difference between the Expenses (% of total expenses) of France in 2009 and the Expenses (% of total expenses) of Iceland in 2010?
Your response must be concise. -16.49. What is the difference between the Expenses (% of total expenses) of France in 2009 and the Expenses (% of total expenses) of Israel in 2010?
Ensure brevity in your answer.  -7. What is the difference between the Expenses (% of total expenses) in Iceland in 2009 and the Expenses (% of total expenses) in Israel in 2010?
Provide a succinct answer. 1.21. What is the average Expenses (% of total expenses) of OECD members per year?
Provide a short and direct response. 6.14. What is the average Expenses (% of total expenses) of France per year?
Ensure brevity in your answer.  1.76. What is the average Expenses (% of total expenses) of Iceland per year?
Provide a succinct answer. 14.25. What is the average Expenses (% of total expenses) of Israel per year?
Ensure brevity in your answer.  8.16. In the year 2003, what is the difference between the Expenses (% of total expenses) of OECD members and Expenses (% of total expenses) of France?
Offer a terse response. 4.11. In the year 2003, what is the difference between the Expenses (% of total expenses) in OECD members and Expenses (% of total expenses) in Iceland?
Provide a short and direct response. -4.58. In the year 2003, what is the difference between the Expenses (% of total expenses) of OECD members and Expenses (% of total expenses) of Israel?
Ensure brevity in your answer.  -0.99. In the year 2003, what is the difference between the Expenses (% of total expenses) in France and Expenses (% of total expenses) in Iceland?
Provide a succinct answer. -8.69. In the year 2003, what is the difference between the Expenses (% of total expenses) of France and Expenses (% of total expenses) of Israel?
Your response must be concise. -5.1. In the year 2003, what is the difference between the Expenses (% of total expenses) of Iceland and Expenses (% of total expenses) of Israel?
Your answer should be compact. 3.6. In the year 2004, what is the difference between the Expenses (% of total expenses) in OECD members and Expenses (% of total expenses) in France?
Provide a succinct answer. 4.37. In the year 2004, what is the difference between the Expenses (% of total expenses) of OECD members and Expenses (% of total expenses) of Iceland?
Your answer should be very brief. -3.63. In the year 2004, what is the difference between the Expenses (% of total expenses) in OECD members and Expenses (% of total expenses) in Israel?
Provide a short and direct response. -1.44. In the year 2004, what is the difference between the Expenses (% of total expenses) in France and Expenses (% of total expenses) in Iceland?
Provide a short and direct response. -7.99. In the year 2004, what is the difference between the Expenses (% of total expenses) of France and Expenses (% of total expenses) of Israel?
Your response must be concise. -5.8. In the year 2004, what is the difference between the Expenses (% of total expenses) in Iceland and Expenses (% of total expenses) in Israel?
Your answer should be compact. 2.19. In the year 2005, what is the difference between the Expenses (% of total expenses) in OECD members and Expenses (% of total expenses) in France?
Give a very brief answer. 3.8. In the year 2005, what is the difference between the Expenses (% of total expenses) of OECD members and Expenses (% of total expenses) of Iceland?
Offer a very short reply. -4.13. In the year 2005, what is the difference between the Expenses (% of total expenses) in OECD members and Expenses (% of total expenses) in Israel?
Make the answer very short. -1.8. In the year 2005, what is the difference between the Expenses (% of total expenses) in France and Expenses (% of total expenses) in Iceland?
Your response must be concise. -7.93. In the year 2005, what is the difference between the Expenses (% of total expenses) of France and Expenses (% of total expenses) of Israel?
Your answer should be very brief. -5.6. In the year 2005, what is the difference between the Expenses (% of total expenses) of Iceland and Expenses (% of total expenses) of Israel?
Provide a short and direct response. 2.33. In the year 2006, what is the difference between the Expenses (% of total expenses) in OECD members and Expenses (% of total expenses) in France?
Keep it short and to the point. 4.04. In the year 2006, what is the difference between the Expenses (% of total expenses) in OECD members and Expenses (% of total expenses) in Iceland?
Provide a short and direct response. -3.77. In the year 2006, what is the difference between the Expenses (% of total expenses) of OECD members and Expenses (% of total expenses) of Israel?
Ensure brevity in your answer.  -2.26. In the year 2006, what is the difference between the Expenses (% of total expenses) of France and Expenses (% of total expenses) of Iceland?
Provide a short and direct response. -7.81. In the year 2006, what is the difference between the Expenses (% of total expenses) of France and Expenses (% of total expenses) of Israel?
Your response must be concise. -6.3. In the year 2006, what is the difference between the Expenses (% of total expenses) of Iceland and Expenses (% of total expenses) of Israel?
Make the answer very short. 1.51. In the year 2007, what is the difference between the Expenses (% of total expenses) in OECD members and Expenses (% of total expenses) in France?
Keep it short and to the point. 4.15. In the year 2007, what is the difference between the Expenses (% of total expenses) of OECD members and Expenses (% of total expenses) of Iceland?
Your answer should be very brief. -3.6. In the year 2007, what is the difference between the Expenses (% of total expenses) in OECD members and Expenses (% of total expenses) in Israel?
Give a very brief answer. -2.36. In the year 2007, what is the difference between the Expenses (% of total expenses) in France and Expenses (% of total expenses) in Iceland?
Your response must be concise. -7.75. In the year 2007, what is the difference between the Expenses (% of total expenses) of France and Expenses (% of total expenses) of Israel?
Offer a terse response. -6.52. In the year 2007, what is the difference between the Expenses (% of total expenses) of Iceland and Expenses (% of total expenses) of Israel?
Provide a succinct answer. 1.23. In the year 2008, what is the difference between the Expenses (% of total expenses) of OECD members and Expenses (% of total expenses) of France?
Provide a succinct answer. 4.3. In the year 2008, what is the difference between the Expenses (% of total expenses) of OECD members and Expenses (% of total expenses) of Iceland?
Offer a very short reply. -30.65. In the year 2008, what is the difference between the Expenses (% of total expenses) of OECD members and Expenses (% of total expenses) of Israel?
Your answer should be very brief. -2.87. In the year 2008, what is the difference between the Expenses (% of total expenses) of France and Expenses (% of total expenses) of Iceland?
Give a very brief answer. -34.94. In the year 2008, what is the difference between the Expenses (% of total expenses) of France and Expenses (% of total expenses) of Israel?
Your answer should be compact. -7.16. In the year 2008, what is the difference between the Expenses (% of total expenses) in Iceland and Expenses (% of total expenses) in Israel?
Offer a terse response. 27.78. In the year 2009, what is the difference between the Expenses (% of total expenses) in OECD members and Expenses (% of total expenses) in France?
Offer a very short reply. 4.52. In the year 2009, what is the difference between the Expenses (% of total expenses) in OECD members and Expenses (% of total expenses) in Iceland?
Offer a terse response. -3.69. In the year 2009, what is the difference between the Expenses (% of total expenses) in OECD members and Expenses (% of total expenses) in Israel?
Offer a very short reply. -3.14. In the year 2009, what is the difference between the Expenses (% of total expenses) of France and Expenses (% of total expenses) of Iceland?
Make the answer very short. -8.21. In the year 2009, what is the difference between the Expenses (% of total expenses) of France and Expenses (% of total expenses) of Israel?
Make the answer very short. -7.66. In the year 2009, what is the difference between the Expenses (% of total expenses) in Iceland and Expenses (% of total expenses) in Israel?
Offer a very short reply. 0.55. In the year 2010, what is the difference between the Expenses (% of total expenses) in OECD members and Expenses (% of total expenses) in France?
Make the answer very short. 5.71. In the year 2010, what is the difference between the Expenses (% of total expenses) of OECD members and Expenses (% of total expenses) of Iceland?
Give a very brief answer. -10.83. In the year 2010, what is the difference between the Expenses (% of total expenses) of OECD members and Expenses (% of total expenses) of Israel?
Offer a very short reply. -1.34. In the year 2010, what is the difference between the Expenses (% of total expenses) in France and Expenses (% of total expenses) in Iceland?
Your response must be concise. -16.54. In the year 2010, what is the difference between the Expenses (% of total expenses) of France and Expenses (% of total expenses) of Israel?
Offer a very short reply. -7.05. In the year 2010, what is the difference between the Expenses (% of total expenses) in Iceland and Expenses (% of total expenses) in Israel?
Your response must be concise. 9.49. What is the ratio of the Expenses (% of total expenses) in OECD members in 2003 to that in 2004?
Keep it short and to the point. 0.93. What is the ratio of the Expenses (% of total expenses) in France in 2003 to that in 2004?
Make the answer very short. 0.91. What is the ratio of the Expenses (% of total expenses) of Iceland in 2003 to that in 2004?
Keep it short and to the point. 1.06. What is the ratio of the Expenses (% of total expenses) of Israel in 2003 to that in 2004?
Provide a succinct answer. 0.89. What is the ratio of the Expenses (% of total expenses) in OECD members in 2003 to that in 2005?
Your answer should be compact. 0.96. What is the ratio of the Expenses (% of total expenses) of France in 2003 to that in 2005?
Ensure brevity in your answer.  0.75. What is the ratio of the Expenses (% of total expenses) in Iceland in 2003 to that in 2005?
Offer a terse response. 1.02. What is the ratio of the Expenses (% of total expenses) in Israel in 2003 to that in 2005?
Provide a short and direct response. 0.86. What is the ratio of the Expenses (% of total expenses) in OECD members in 2003 to that in 2006?
Provide a short and direct response. 0.95. What is the ratio of the Expenses (% of total expenses) of France in 2003 to that in 2006?
Your answer should be very brief. 0.81. What is the ratio of the Expenses (% of total expenses) in Iceland in 2003 to that in 2006?
Your answer should be very brief. 1.05. What is the ratio of the Expenses (% of total expenses) in Israel in 2003 to that in 2006?
Make the answer very short. 0.81. What is the ratio of the Expenses (% of total expenses) in OECD members in 2003 to that in 2007?
Offer a terse response. 0.93. What is the ratio of the Expenses (% of total expenses) of France in 2003 to that in 2007?
Your response must be concise. 0.81. What is the ratio of the Expenses (% of total expenses) of Iceland in 2003 to that in 2007?
Provide a succinct answer. 1.06. What is the ratio of the Expenses (% of total expenses) of Israel in 2003 to that in 2007?
Keep it short and to the point. 0.79. What is the ratio of the Expenses (% of total expenses) in OECD members in 2003 to that in 2008?
Provide a succinct answer. 0.95. What is the ratio of the Expenses (% of total expenses) of France in 2003 to that in 2008?
Provide a succinct answer. 0.94. What is the ratio of the Expenses (% of total expenses) in Iceland in 2003 to that in 2008?
Your response must be concise. 0.28. What is the ratio of the Expenses (% of total expenses) in Israel in 2003 to that in 2008?
Give a very brief answer. 0.75. What is the ratio of the Expenses (% of total expenses) of OECD members in 2003 to that in 2009?
Offer a terse response. 0.92. What is the ratio of the Expenses (% of total expenses) of France in 2003 to that in 2009?
Offer a very short reply. 0.96. What is the ratio of the Expenses (% of total expenses) of Iceland in 2003 to that in 2009?
Provide a succinct answer. 1.04. What is the ratio of the Expenses (% of total expenses) of Israel in 2003 to that in 2009?
Provide a short and direct response. 0.72. What is the ratio of the Expenses (% of total expenses) of OECD members in 2003 to that in 2010?
Your answer should be very brief. 0.78. What is the ratio of the Expenses (% of total expenses) in France in 2003 to that in 2010?
Your answer should be compact. 0.99. What is the ratio of the Expenses (% of total expenses) of Iceland in 2003 to that in 2010?
Keep it short and to the point. 0.57. What is the ratio of the Expenses (% of total expenses) of Israel in 2003 to that in 2010?
Make the answer very short. 0.77. What is the ratio of the Expenses (% of total expenses) in OECD members in 2004 to that in 2005?
Provide a short and direct response. 1.03. What is the ratio of the Expenses (% of total expenses) of France in 2004 to that in 2005?
Provide a succinct answer. 0.82. What is the ratio of the Expenses (% of total expenses) of Iceland in 2004 to that in 2005?
Offer a terse response. 0.97. What is the ratio of the Expenses (% of total expenses) in Israel in 2004 to that in 2005?
Offer a very short reply. 0.98. What is the ratio of the Expenses (% of total expenses) in OECD members in 2004 to that in 2006?
Give a very brief answer. 1.02. What is the ratio of the Expenses (% of total expenses) of France in 2004 to that in 2006?
Ensure brevity in your answer.  0.88. What is the ratio of the Expenses (% of total expenses) in Israel in 2004 to that in 2006?
Offer a very short reply. 0.91. What is the ratio of the Expenses (% of total expenses) of France in 2004 to that in 2007?
Provide a succinct answer. 0.88. What is the ratio of the Expenses (% of total expenses) in Israel in 2004 to that in 2007?
Give a very brief answer. 0.89. What is the ratio of the Expenses (% of total expenses) of OECD members in 2004 to that in 2008?
Offer a terse response. 1.02. What is the ratio of the Expenses (% of total expenses) in France in 2004 to that in 2008?
Provide a short and direct response. 1.02. What is the ratio of the Expenses (% of total expenses) in Iceland in 2004 to that in 2008?
Give a very brief answer. 0.27. What is the ratio of the Expenses (% of total expenses) in Israel in 2004 to that in 2008?
Your answer should be very brief. 0.85. What is the ratio of the Expenses (% of total expenses) of OECD members in 2004 to that in 2009?
Provide a succinct answer. 0.99. What is the ratio of the Expenses (% of total expenses) of France in 2004 to that in 2009?
Your response must be concise. 1.05. What is the ratio of the Expenses (% of total expenses) in Iceland in 2004 to that in 2009?
Your answer should be compact. 0.99. What is the ratio of the Expenses (% of total expenses) of Israel in 2004 to that in 2009?
Offer a terse response. 0.81. What is the ratio of the Expenses (% of total expenses) in OECD members in 2004 to that in 2010?
Keep it short and to the point. 0.83. What is the ratio of the Expenses (% of total expenses) of France in 2004 to that in 2010?
Provide a short and direct response. 1.08. What is the ratio of the Expenses (% of total expenses) in Iceland in 2004 to that in 2010?
Ensure brevity in your answer.  0.54. What is the ratio of the Expenses (% of total expenses) of Israel in 2004 to that in 2010?
Give a very brief answer. 0.87. What is the ratio of the Expenses (% of total expenses) of France in 2005 to that in 2006?
Make the answer very short. 1.08. What is the ratio of the Expenses (% of total expenses) of Iceland in 2005 to that in 2006?
Offer a terse response. 1.03. What is the ratio of the Expenses (% of total expenses) of Israel in 2005 to that in 2006?
Provide a succinct answer. 0.93. What is the ratio of the Expenses (% of total expenses) of OECD members in 2005 to that in 2007?
Your answer should be compact. 0.97. What is the ratio of the Expenses (% of total expenses) in France in 2005 to that in 2007?
Offer a terse response. 1.08. What is the ratio of the Expenses (% of total expenses) in Iceland in 2005 to that in 2007?
Ensure brevity in your answer.  1.04. What is the ratio of the Expenses (% of total expenses) of Israel in 2005 to that in 2007?
Your answer should be very brief. 0.91. What is the ratio of the Expenses (% of total expenses) of OECD members in 2005 to that in 2008?
Make the answer very short. 0.99. What is the ratio of the Expenses (% of total expenses) of France in 2005 to that in 2008?
Your answer should be compact. 1.25. What is the ratio of the Expenses (% of total expenses) in Iceland in 2005 to that in 2008?
Give a very brief answer. 0.27. What is the ratio of the Expenses (% of total expenses) in Israel in 2005 to that in 2008?
Offer a very short reply. 0.87. What is the ratio of the Expenses (% of total expenses) of OECD members in 2005 to that in 2009?
Your answer should be compact. 0.96. What is the ratio of the Expenses (% of total expenses) of France in 2005 to that in 2009?
Make the answer very short. 1.29. What is the ratio of the Expenses (% of total expenses) of Iceland in 2005 to that in 2009?
Keep it short and to the point. 1.02. What is the ratio of the Expenses (% of total expenses) in Israel in 2005 to that in 2009?
Your answer should be compact. 0.83. What is the ratio of the Expenses (% of total expenses) in OECD members in 2005 to that in 2010?
Offer a terse response. 0.81. What is the ratio of the Expenses (% of total expenses) of France in 2005 to that in 2010?
Your answer should be compact. 1.33. What is the ratio of the Expenses (% of total expenses) in Iceland in 2005 to that in 2010?
Your answer should be compact. 0.55. What is the ratio of the Expenses (% of total expenses) in Israel in 2005 to that in 2010?
Provide a short and direct response. 0.89. What is the ratio of the Expenses (% of total expenses) of OECD members in 2006 to that in 2007?
Provide a succinct answer. 0.98. What is the ratio of the Expenses (% of total expenses) in France in 2006 to that in 2007?
Offer a terse response. 1.01. What is the ratio of the Expenses (% of total expenses) of Iceland in 2006 to that in 2007?
Provide a short and direct response. 1.01. What is the ratio of the Expenses (% of total expenses) of Israel in 2006 to that in 2007?
Ensure brevity in your answer.  0.98. What is the ratio of the Expenses (% of total expenses) in OECD members in 2006 to that in 2008?
Your response must be concise. 1. What is the ratio of the Expenses (% of total expenses) of France in 2006 to that in 2008?
Ensure brevity in your answer.  1.16. What is the ratio of the Expenses (% of total expenses) in Iceland in 2006 to that in 2008?
Give a very brief answer. 0.27. What is the ratio of the Expenses (% of total expenses) in Israel in 2006 to that in 2008?
Offer a very short reply. 0.93. What is the ratio of the Expenses (% of total expenses) in OECD members in 2006 to that in 2009?
Provide a short and direct response. 0.97. What is the ratio of the Expenses (% of total expenses) in France in 2006 to that in 2009?
Give a very brief answer. 1.19. What is the ratio of the Expenses (% of total expenses) of Iceland in 2006 to that in 2009?
Offer a very short reply. 0.99. What is the ratio of the Expenses (% of total expenses) in Israel in 2006 to that in 2009?
Give a very brief answer. 0.89. What is the ratio of the Expenses (% of total expenses) in OECD members in 2006 to that in 2010?
Provide a short and direct response. 0.82. What is the ratio of the Expenses (% of total expenses) of France in 2006 to that in 2010?
Ensure brevity in your answer.  1.23. What is the ratio of the Expenses (% of total expenses) in Iceland in 2006 to that in 2010?
Your answer should be very brief. 0.54. What is the ratio of the Expenses (% of total expenses) of Israel in 2006 to that in 2010?
Offer a very short reply. 0.96. What is the ratio of the Expenses (% of total expenses) of OECD members in 2007 to that in 2008?
Provide a succinct answer. 1.02. What is the ratio of the Expenses (% of total expenses) of France in 2007 to that in 2008?
Ensure brevity in your answer.  1.16. What is the ratio of the Expenses (% of total expenses) in Iceland in 2007 to that in 2008?
Your answer should be compact. 0.26. What is the ratio of the Expenses (% of total expenses) of Israel in 2007 to that in 2008?
Give a very brief answer. 0.96. What is the ratio of the Expenses (% of total expenses) in OECD members in 2007 to that in 2009?
Keep it short and to the point. 0.99. What is the ratio of the Expenses (% of total expenses) of France in 2007 to that in 2009?
Offer a very short reply. 1.19. What is the ratio of the Expenses (% of total expenses) in Israel in 2007 to that in 2009?
Make the answer very short. 0.91. What is the ratio of the Expenses (% of total expenses) in OECD members in 2007 to that in 2010?
Provide a succinct answer. 0.84. What is the ratio of the Expenses (% of total expenses) in France in 2007 to that in 2010?
Give a very brief answer. 1.22. What is the ratio of the Expenses (% of total expenses) in Iceland in 2007 to that in 2010?
Offer a very short reply. 0.53. What is the ratio of the Expenses (% of total expenses) in Israel in 2007 to that in 2010?
Your response must be concise. 0.98. What is the ratio of the Expenses (% of total expenses) of OECD members in 2008 to that in 2009?
Your answer should be very brief. 0.97. What is the ratio of the Expenses (% of total expenses) of France in 2008 to that in 2009?
Ensure brevity in your answer.  1.03. What is the ratio of the Expenses (% of total expenses) of Iceland in 2008 to that in 2009?
Provide a short and direct response. 3.72. What is the ratio of the Expenses (% of total expenses) in Israel in 2008 to that in 2009?
Give a very brief answer. 0.95. What is the ratio of the Expenses (% of total expenses) of OECD members in 2008 to that in 2010?
Your response must be concise. 0.82. What is the ratio of the Expenses (% of total expenses) in France in 2008 to that in 2010?
Ensure brevity in your answer.  1.06. What is the ratio of the Expenses (% of total expenses) of Iceland in 2008 to that in 2010?
Provide a succinct answer. 2.02. What is the ratio of the Expenses (% of total expenses) of Israel in 2008 to that in 2010?
Ensure brevity in your answer.  1.02. What is the ratio of the Expenses (% of total expenses) in OECD members in 2009 to that in 2010?
Give a very brief answer. 0.84. What is the ratio of the Expenses (% of total expenses) in France in 2009 to that in 2010?
Your response must be concise. 1.03. What is the ratio of the Expenses (% of total expenses) in Iceland in 2009 to that in 2010?
Provide a succinct answer. 0.54. What is the ratio of the Expenses (% of total expenses) in Israel in 2009 to that in 2010?
Keep it short and to the point. 1.08. What is the difference between the highest and the second highest Expenses (% of total expenses) of OECD members?
Your answer should be very brief. 1.14. What is the difference between the highest and the second highest Expenses (% of total expenses) of France?
Keep it short and to the point. 0.15. What is the difference between the highest and the second highest Expenses (% of total expenses) in Iceland?
Provide a succinct answer. 18.5. What is the difference between the highest and the second highest Expenses (% of total expenses) of Israel?
Ensure brevity in your answer.  0.45. What is the difference between the highest and the lowest Expenses (% of total expenses) of OECD members?
Make the answer very short. 1.61. What is the difference between the highest and the lowest Expenses (% of total expenses) in France?
Make the answer very short. 0.53. What is the difference between the highest and the lowest Expenses (% of total expenses) of Iceland?
Provide a short and direct response. 26.93. What is the difference between the highest and the lowest Expenses (% of total expenses) of Israel?
Ensure brevity in your answer.  2.63. 